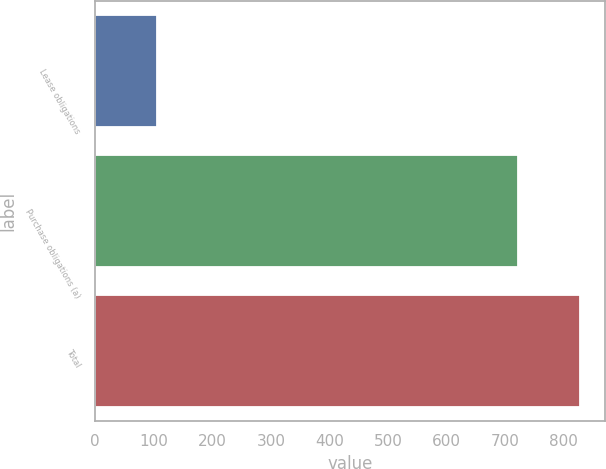<chart> <loc_0><loc_0><loc_500><loc_500><bar_chart><fcel>Lease obligations<fcel>Purchase obligations (a)<fcel>Total<nl><fcel>106<fcel>722<fcel>828<nl></chart> 